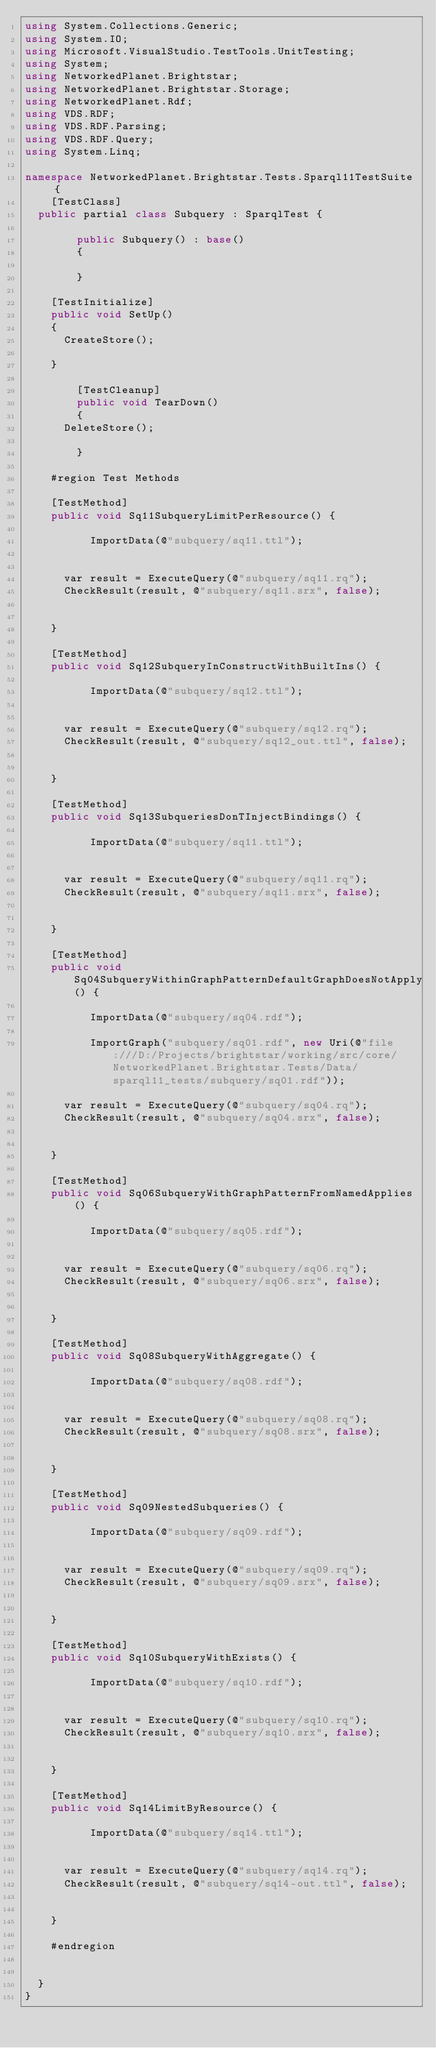<code> <loc_0><loc_0><loc_500><loc_500><_C#_>using System.Collections.Generic;
using System.IO;
using Microsoft.VisualStudio.TestTools.UnitTesting;
using System;
using NetworkedPlanet.Brightstar;
using NetworkedPlanet.Brightstar.Storage;
using NetworkedPlanet.Rdf;
using VDS.RDF;
using VDS.RDF.Parsing;
using VDS.RDF.Query;
using System.Linq;

namespace NetworkedPlanet.Brightstar.Tests.Sparql11TestSuite {
    [TestClass]
	public partial class Subquery : SparqlTest {

        public Subquery() : base()
        {
            
        }

		[TestInitialize]
		public void SetUp()
		{
			CreateStore();
		    
		}

        [TestCleanup]
        public void TearDown()
        {
			DeleteStore();
            
        }

		#region Test Methods

		[TestMethod]
		public void Sq11SubqueryLimitPerResource() {
	
					ImportData(@"subquery/sq11.ttl");
		
		
			var result = ExecuteQuery(@"subquery/sq11.rq");
			CheckResult(result, @"subquery/sq11.srx", false);

	
		}

		[TestMethod]
		public void Sq12SubqueryInConstructWithBuiltIns() {
	
					ImportData(@"subquery/sq12.ttl");
		
		
			var result = ExecuteQuery(@"subquery/sq12.rq");
			CheckResult(result, @"subquery/sq12_out.ttl", false);

	
		}

		[TestMethod]
		public void Sq13SubqueriesDonTInjectBindings() {
	
					ImportData(@"subquery/sq11.ttl");
		
		
			var result = ExecuteQuery(@"subquery/sq11.rq");
			CheckResult(result, @"subquery/sq11.srx", false);

	
		}

		[TestMethod]
		public void Sq04SubqueryWithinGraphPatternDefaultGraphDoesNotApply() {
	
					ImportData(@"subquery/sq04.rdf");
		
					ImportGraph("subquery/sq01.rdf", new Uri(@"file:///D:/Projects/brightstar/working/src/core/NetworkedPlanet.Brightstar.Tests/Data/sparql11_tests/subquery/sq01.rdf"));
		
			var result = ExecuteQuery(@"subquery/sq04.rq");
			CheckResult(result, @"subquery/sq04.srx", false);

	
		}

		[TestMethod]
		public void Sq06SubqueryWithGraphPatternFromNamedApplies() {
	
					ImportData(@"subquery/sq05.rdf");
		
		
			var result = ExecuteQuery(@"subquery/sq06.rq");
			CheckResult(result, @"subquery/sq06.srx", false);

	
		}

		[TestMethod]
		public void Sq08SubqueryWithAggregate() {
	
					ImportData(@"subquery/sq08.rdf");
		
		
			var result = ExecuteQuery(@"subquery/sq08.rq");
			CheckResult(result, @"subquery/sq08.srx", false);

	
		}

		[TestMethod]
		public void Sq09NestedSubqueries() {
	
					ImportData(@"subquery/sq09.rdf");
		
		
			var result = ExecuteQuery(@"subquery/sq09.rq");
			CheckResult(result, @"subquery/sq09.srx", false);

	
		}

		[TestMethod]
		public void Sq10SubqueryWithExists() {
	
					ImportData(@"subquery/sq10.rdf");
		
		
			var result = ExecuteQuery(@"subquery/sq10.rq");
			CheckResult(result, @"subquery/sq10.srx", false);

	
		}

		[TestMethod]
		public void Sq14LimitByResource() {
	
					ImportData(@"subquery/sq14.ttl");
		
		
			var result = ExecuteQuery(@"subquery/sq14.rq");
			CheckResult(result, @"subquery/sq14-out.ttl", false);

	
		}

		#endregion

		
	}
}</code> 